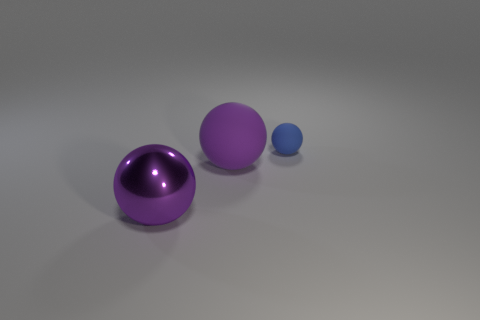Subtract all rubber spheres. How many spheres are left? 1 Subtract all blue balls. How many balls are left? 2 Subtract all blue rubber spheres. Subtract all small blue spheres. How many objects are left? 1 Add 3 purple objects. How many purple objects are left? 5 Add 2 purple rubber objects. How many purple rubber objects exist? 3 Add 3 purple shiny spheres. How many objects exist? 6 Subtract 0 blue cylinders. How many objects are left? 3 Subtract all red spheres. Subtract all purple cylinders. How many spheres are left? 3 Subtract all cyan cylinders. How many blue spheres are left? 1 